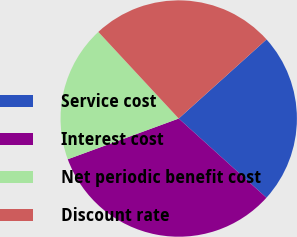Convert chart. <chart><loc_0><loc_0><loc_500><loc_500><pie_chart><fcel>Service cost<fcel>Interest cost<fcel>Net periodic benefit cost<fcel>Discount rate<nl><fcel>23.36%<fcel>32.71%<fcel>18.69%<fcel>25.23%<nl></chart> 